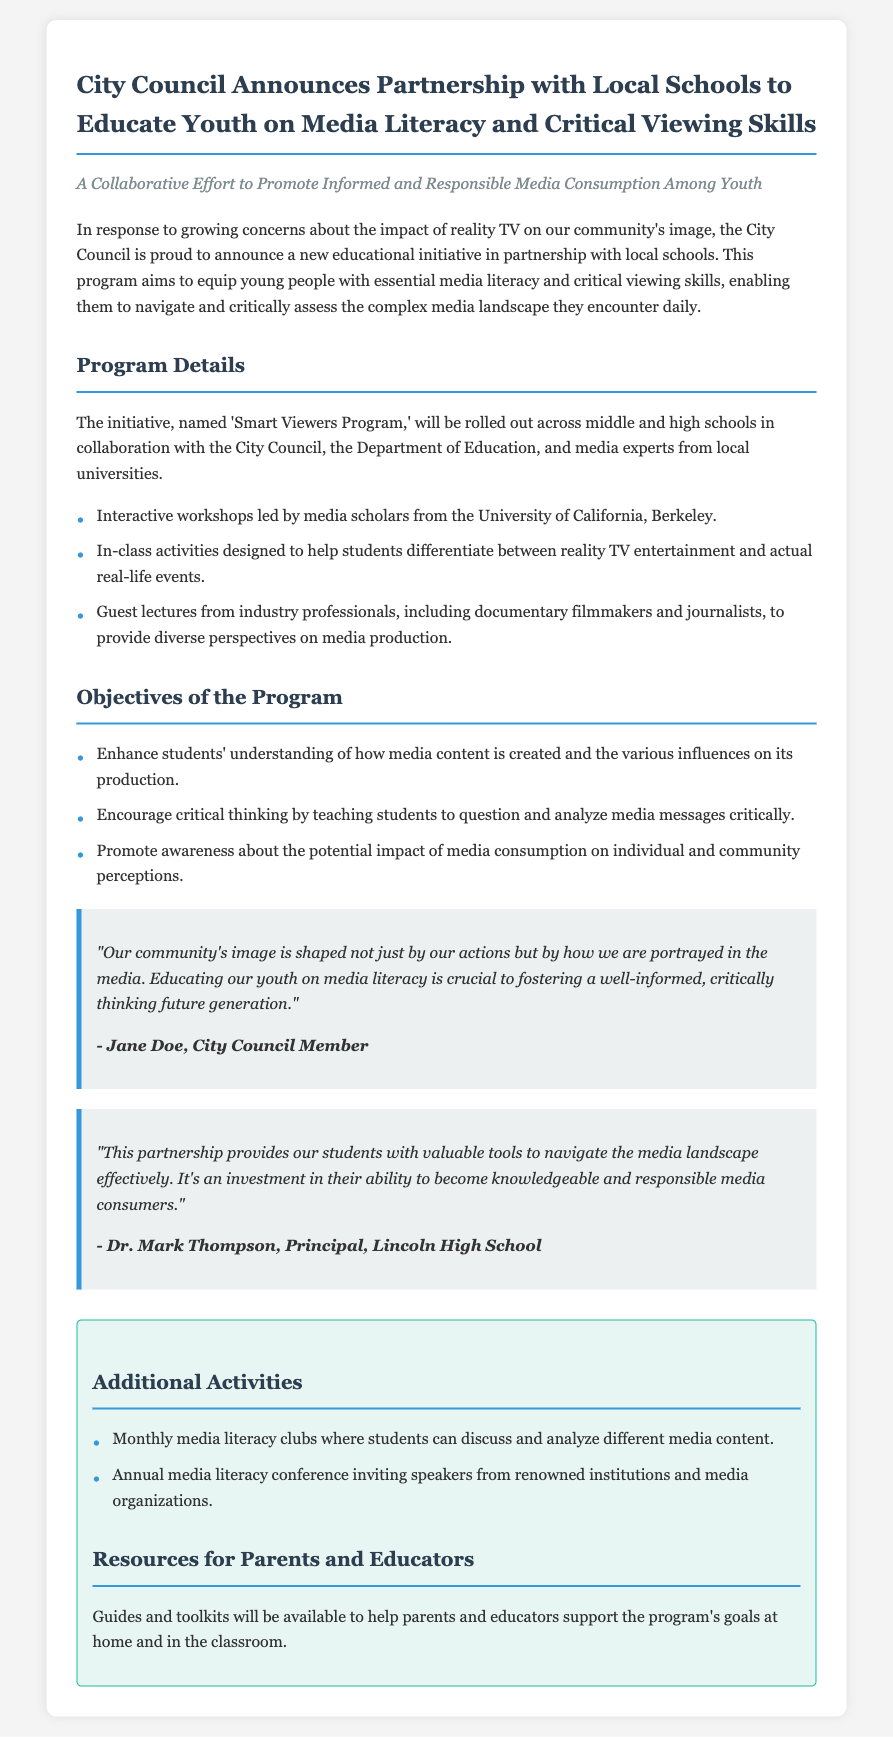What is the name of the program? The program is titled 'Smart Viewers Program' as stated in the document.
Answer: Smart Viewers Program Who is leading the interactive workshops? The workshops are led by media scholars from the University of California, Berkeley.
Answer: University of California, Berkeley What is one objective of the program? One objective is to enhance students' understanding of how media content is created.
Answer: Enhance students' understanding of media content creation What additional activity is proposed for students? Monthly media literacy clubs are proposed for discussing and analyzing media content.
Answer: Monthly media literacy clubs Who provided a quote in the press release? Jane Doe, a City Council Member, provided a quote regarding the program.
Answer: Jane Doe What is the main concern that prompted this initiative? The initiative responds to concerns about the impact of reality TV on the community's image.
Answer: Impact of reality TV What will be available for parents and educators? Guides and toolkits will be available to support the program's goals.
Answer: Guides and toolkits How many schools are included in the program? The program will be rolled out across middle and high schools.
Answer: Middle and high schools What type of professionals will give guest lectures? Industry professionals, including documentary filmmakers and journalists, will give guest lectures.
Answer: Documentary filmmakers and journalists 